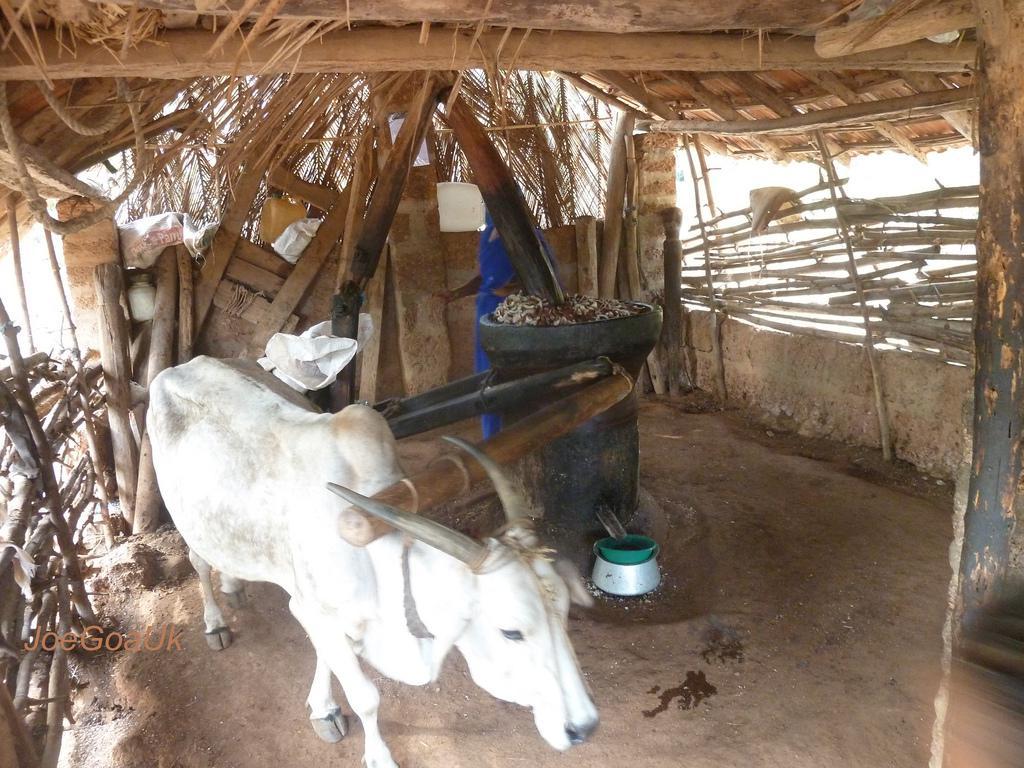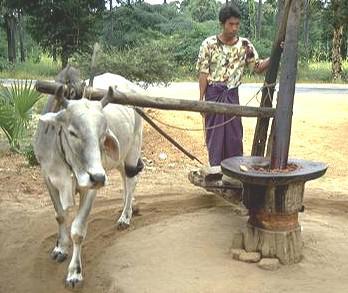The first image is the image on the left, the second image is the image on the right. Given the left and right images, does the statement "The man attending the cow in one of the photos is shirtless." hold true? Answer yes or no. No. The first image is the image on the left, the second image is the image on the right. Evaluate the accuracy of this statement regarding the images: "There is a green bowl under a spout that comes out from the mill in the left image.". Is it true? Answer yes or no. Yes. 